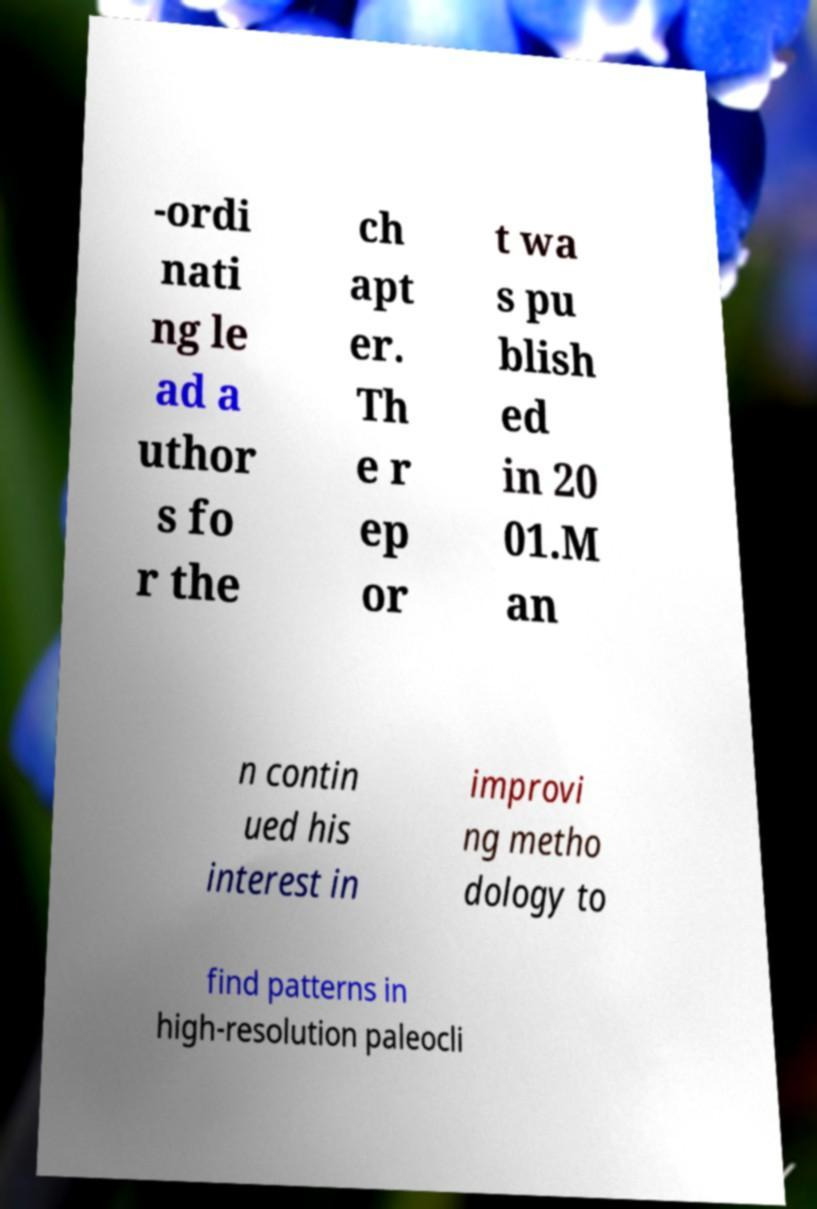Could you extract and type out the text from this image? -ordi nati ng le ad a uthor s fo r the ch apt er. Th e r ep or t wa s pu blish ed in 20 01.M an n contin ued his interest in improvi ng metho dology to find patterns in high-resolution paleocli 